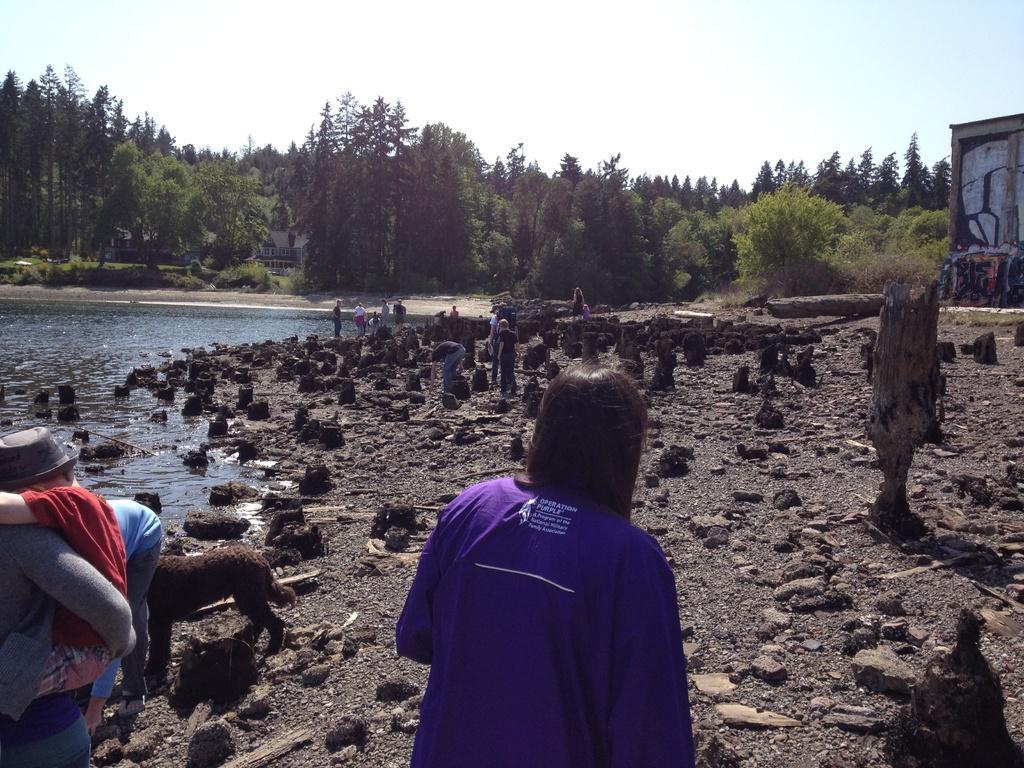Describe this image in one or two sentences. In this image there is a woman standing on the ground. In front of her there are cut down tree pieces. At the top there is sky. On the right side there is a wall. In front of her there are trees. On the ground there is sand and stem pieces. On the left side there are few other people standing on the ground and there is a lake in front of them and also there is an animal on the ground. 